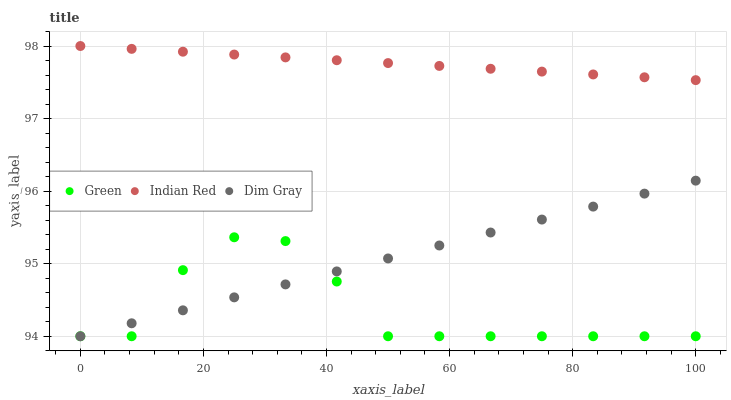Does Green have the minimum area under the curve?
Answer yes or no. Yes. Does Indian Red have the maximum area under the curve?
Answer yes or no. Yes. Does Indian Red have the minimum area under the curve?
Answer yes or no. No. Does Green have the maximum area under the curve?
Answer yes or no. No. Is Indian Red the smoothest?
Answer yes or no. Yes. Is Green the roughest?
Answer yes or no. Yes. Is Green the smoothest?
Answer yes or no. No. Is Indian Red the roughest?
Answer yes or no. No. Does Dim Gray have the lowest value?
Answer yes or no. Yes. Does Indian Red have the lowest value?
Answer yes or no. No. Does Indian Red have the highest value?
Answer yes or no. Yes. Does Green have the highest value?
Answer yes or no. No. Is Dim Gray less than Indian Red?
Answer yes or no. Yes. Is Indian Red greater than Dim Gray?
Answer yes or no. Yes. Does Green intersect Dim Gray?
Answer yes or no. Yes. Is Green less than Dim Gray?
Answer yes or no. No. Is Green greater than Dim Gray?
Answer yes or no. No. Does Dim Gray intersect Indian Red?
Answer yes or no. No. 